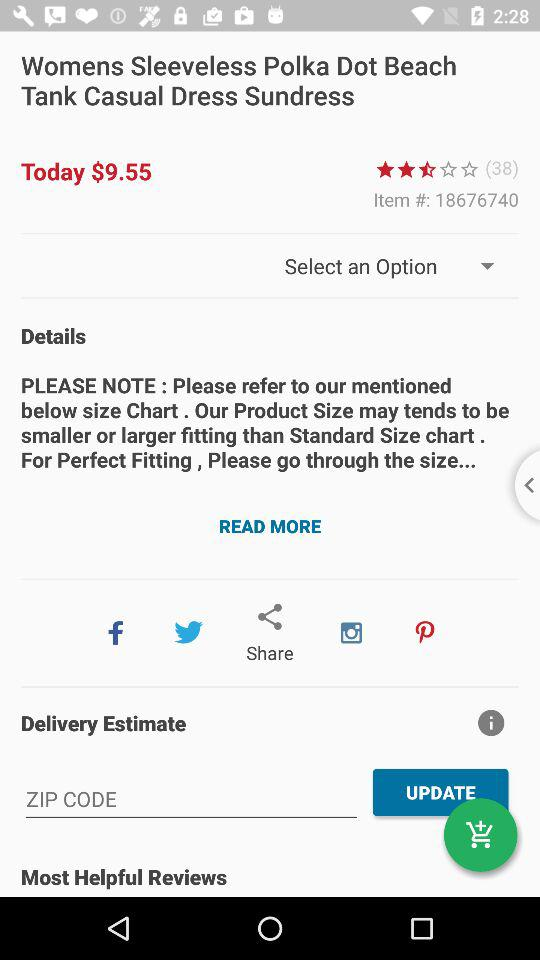What is the item ID? The item ID is 18676740. 